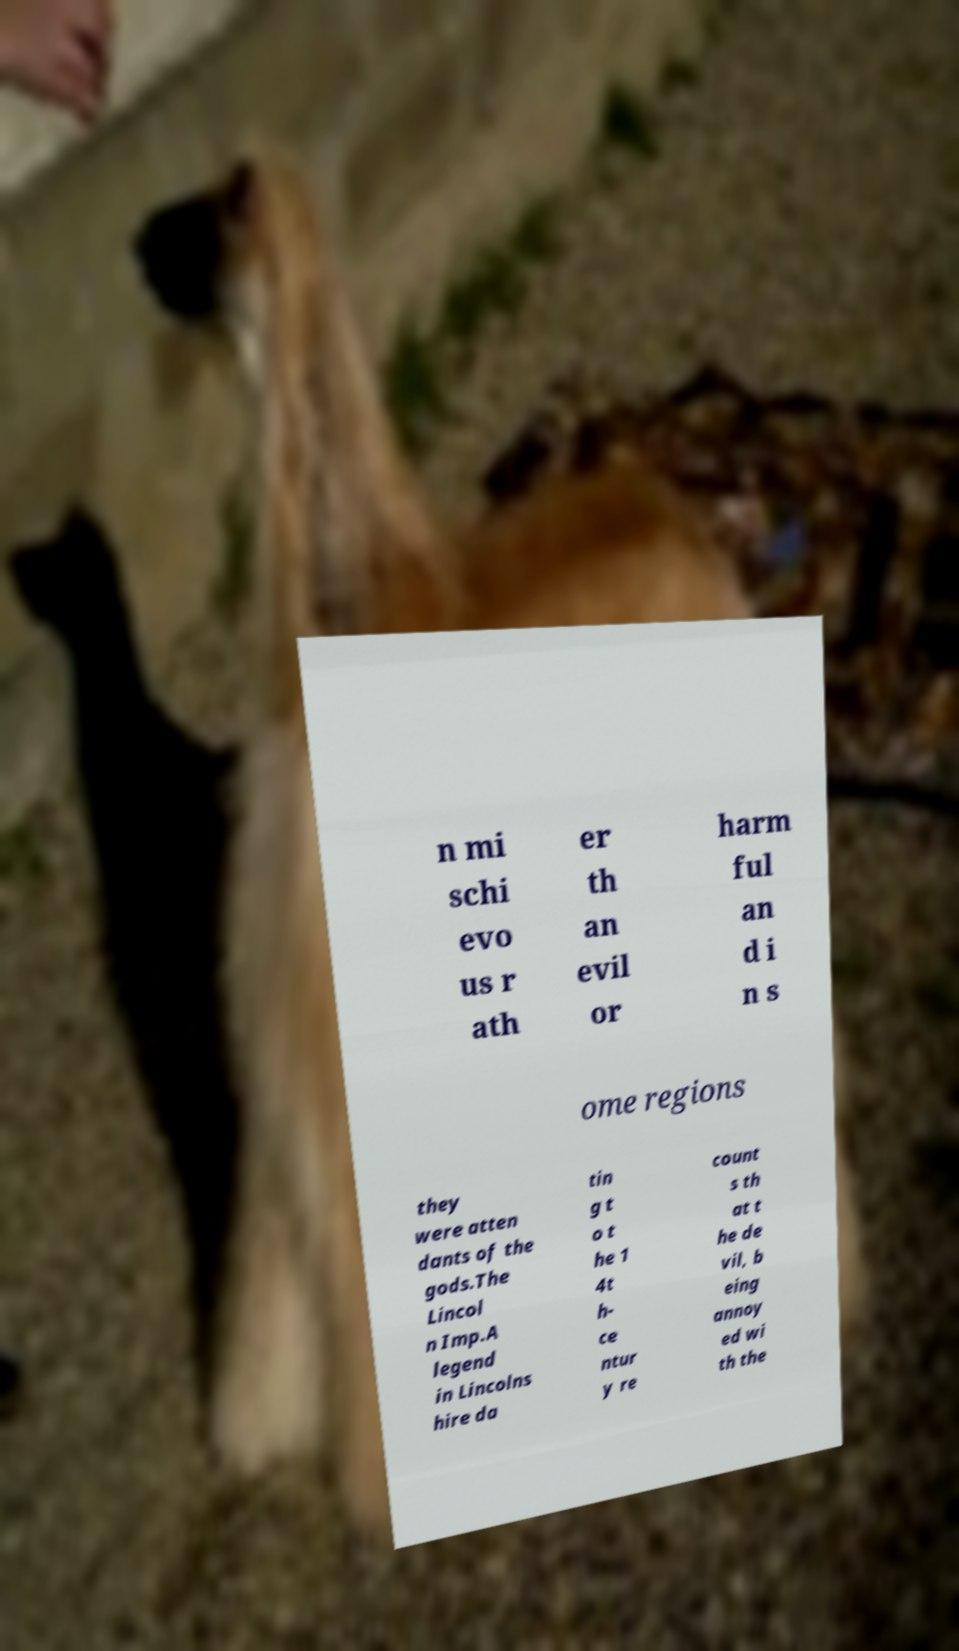Please read and relay the text visible in this image. What does it say? n mi schi evo us r ath er th an evil or harm ful an d i n s ome regions they were atten dants of the gods.The Lincol n Imp.A legend in Lincolns hire da tin g t o t he 1 4t h- ce ntur y re count s th at t he de vil, b eing annoy ed wi th the 